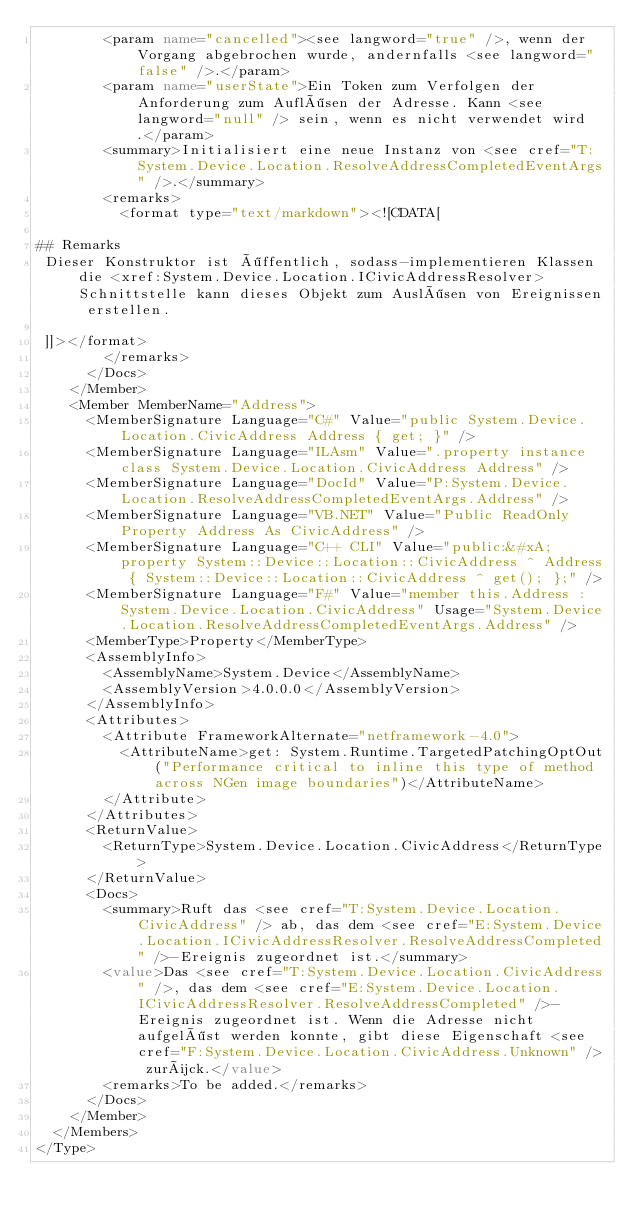<code> <loc_0><loc_0><loc_500><loc_500><_XML_>        <param name="cancelled"><see langword="true" />, wenn der Vorgang abgebrochen wurde, andernfalls <see langword="false" />.</param>
        <param name="userState">Ein Token zum Verfolgen der Anforderung zum Auflösen der Adresse. Kann <see langword="null" /> sein, wenn es nicht verwendet wird.</param>
        <summary>Initialisiert eine neue Instanz von <see cref="T:System.Device.Location.ResolveAddressCompletedEventArgs" />.</summary>
        <remarks>
          <format type="text/markdown"><![CDATA[  
  
## Remarks  
 Dieser Konstruktor ist öffentlich, sodass-implementieren Klassen die <xref:System.Device.Location.ICivicAddressResolver> Schnittstelle kann dieses Objekt zum Auslösen von Ereignissen erstellen.  
  
 ]]></format>
        </remarks>
      </Docs>
    </Member>
    <Member MemberName="Address">
      <MemberSignature Language="C#" Value="public System.Device.Location.CivicAddress Address { get; }" />
      <MemberSignature Language="ILAsm" Value=".property instance class System.Device.Location.CivicAddress Address" />
      <MemberSignature Language="DocId" Value="P:System.Device.Location.ResolveAddressCompletedEventArgs.Address" />
      <MemberSignature Language="VB.NET" Value="Public ReadOnly Property Address As CivicAddress" />
      <MemberSignature Language="C++ CLI" Value="public:&#xA; property System::Device::Location::CivicAddress ^ Address { System::Device::Location::CivicAddress ^ get(); };" />
      <MemberSignature Language="F#" Value="member this.Address : System.Device.Location.CivicAddress" Usage="System.Device.Location.ResolveAddressCompletedEventArgs.Address" />
      <MemberType>Property</MemberType>
      <AssemblyInfo>
        <AssemblyName>System.Device</AssemblyName>
        <AssemblyVersion>4.0.0.0</AssemblyVersion>
      </AssemblyInfo>
      <Attributes>
        <Attribute FrameworkAlternate="netframework-4.0">
          <AttributeName>get: System.Runtime.TargetedPatchingOptOut("Performance critical to inline this type of method across NGen image boundaries")</AttributeName>
        </Attribute>
      </Attributes>
      <ReturnValue>
        <ReturnType>System.Device.Location.CivicAddress</ReturnType>
      </ReturnValue>
      <Docs>
        <summary>Ruft das <see cref="T:System.Device.Location.CivicAddress" /> ab, das dem <see cref="E:System.Device.Location.ICivicAddressResolver.ResolveAddressCompleted" />-Ereignis zugeordnet ist.</summary>
        <value>Das <see cref="T:System.Device.Location.CivicAddress" />, das dem <see cref="E:System.Device.Location.ICivicAddressResolver.ResolveAddressCompleted" />-Ereignis zugeordnet ist. Wenn die Adresse nicht aufgelöst werden konnte, gibt diese Eigenschaft <see cref="F:System.Device.Location.CivicAddress.Unknown" /> zurück.</value>
        <remarks>To be added.</remarks>
      </Docs>
    </Member>
  </Members>
</Type></code> 